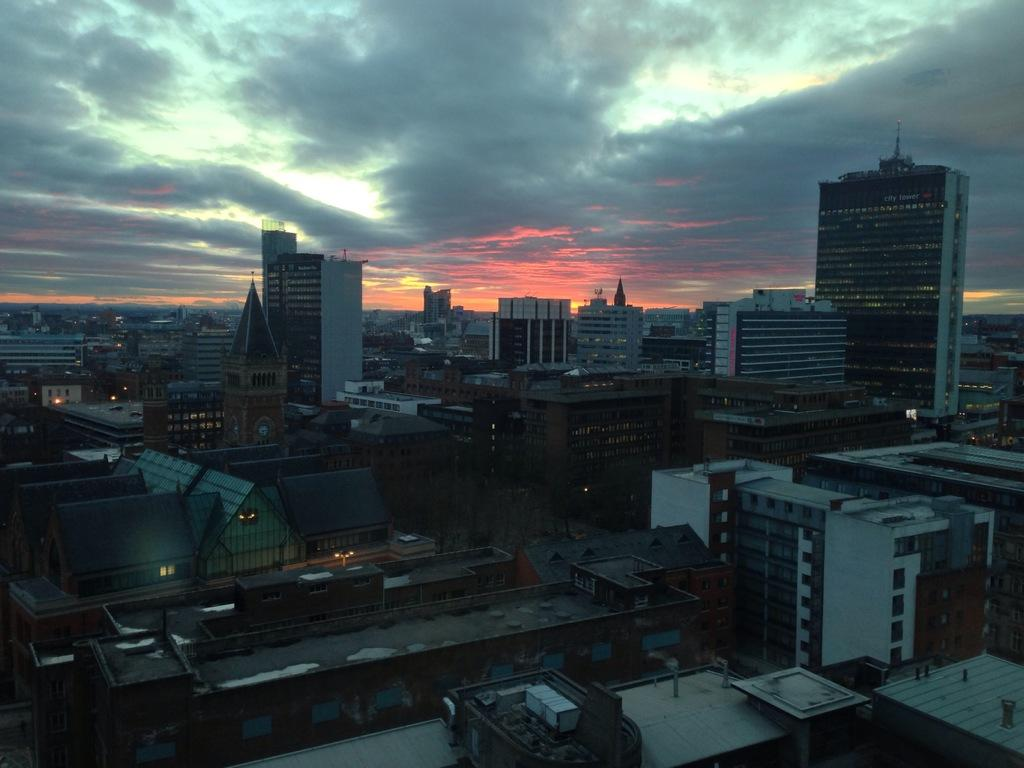What structures are present in the image? There are buildings in the image. What part of the natural environment is visible in the image? The sky is visible in the background of the image. What type of polish is being applied to the circle in the image? There is no circle or polish present in the image; it features buildings and the sky. 